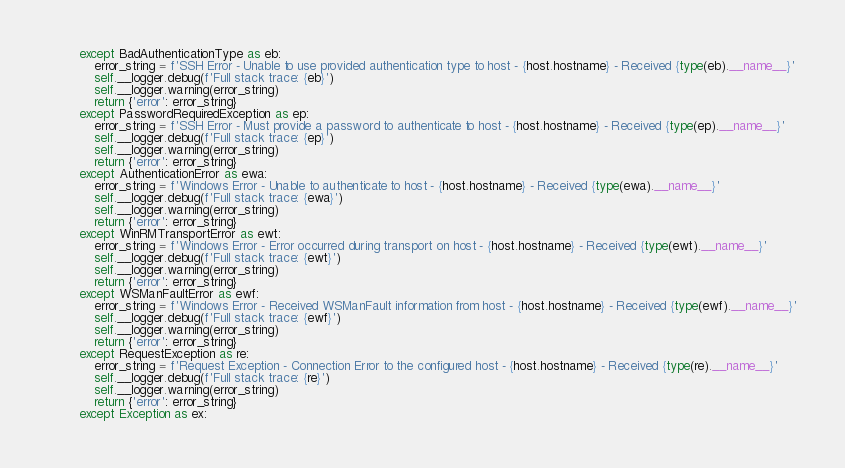Convert code to text. <code><loc_0><loc_0><loc_500><loc_500><_Python_>        except BadAuthenticationType as eb:
            error_string = f'SSH Error - Unable to use provided authentication type to host - {host.hostname} - Received {type(eb).__name__}'
            self.__logger.debug(f'Full stack trace: {eb}')
            self.__logger.warning(error_string)
            return {'error': error_string}
        except PasswordRequiredException as ep:
            error_string = f'SSH Error - Must provide a password to authenticate to host - {host.hostname} - Received {type(ep).__name__}'
            self.__logger.debug(f'Full stack trace: {ep}')
            self.__logger.warning(error_string)
            return {'error': error_string}
        except AuthenticationError as ewa:
            error_string = f'Windows Error - Unable to authenticate to host - {host.hostname} - Received {type(ewa).__name__}'
            self.__logger.debug(f'Full stack trace: {ewa}')
            self.__logger.warning(error_string)
            return {'error': error_string}
        except WinRMTransportError as ewt:
            error_string = f'Windows Error - Error occurred during transport on host - {host.hostname} - Received {type(ewt).__name__}'
            self.__logger.debug(f'Full stack trace: {ewt}')
            self.__logger.warning(error_string)
            return {'error': error_string}
        except WSManFaultError as ewf:
            error_string = f'Windows Error - Received WSManFault information from host - {host.hostname} - Received {type(ewf).__name__}'
            self.__logger.debug(f'Full stack trace: {ewf}')
            self.__logger.warning(error_string)
            return {'error': error_string}
        except RequestException as re:
            error_string = f'Request Exception - Connection Error to the configured host - {host.hostname} - Received {type(re).__name__}'
            self.__logger.debug(f'Full stack trace: {re}')
            self.__logger.warning(error_string)
            return {'error': error_string}
        except Exception as ex:</code> 